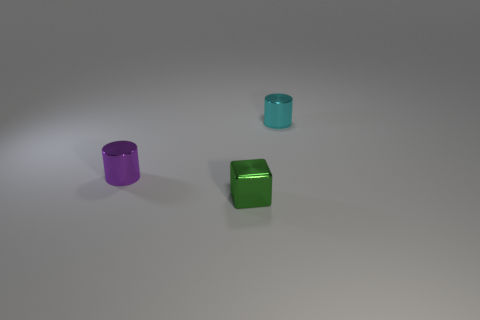The purple metallic thing has what size?
Give a very brief answer. Small. There is a small metallic block; is its color the same as the tiny cylinder that is in front of the cyan cylinder?
Your answer should be very brief. No. What is the color of the metallic thing that is right of the tiny cube on the left side of the cyan shiny thing?
Ensure brevity in your answer.  Cyan. Is there any other thing that has the same size as the block?
Offer a very short reply. Yes. There is a metal thing in front of the tiny purple cylinder; does it have the same shape as the tiny purple object?
Give a very brief answer. No. How many objects are both behind the tiny green metal block and on the right side of the small purple metallic thing?
Offer a very short reply. 1. There is a tiny shiny object that is to the right of the object in front of the metal cylinder on the left side of the cyan object; what color is it?
Your answer should be very brief. Cyan. There is a cylinder left of the small cyan thing; how many small objects are left of it?
Offer a terse response. 0. How many other objects are the same shape as the purple object?
Make the answer very short. 1. How many objects are either tiny metallic cubes or things in front of the purple object?
Your response must be concise. 1. 